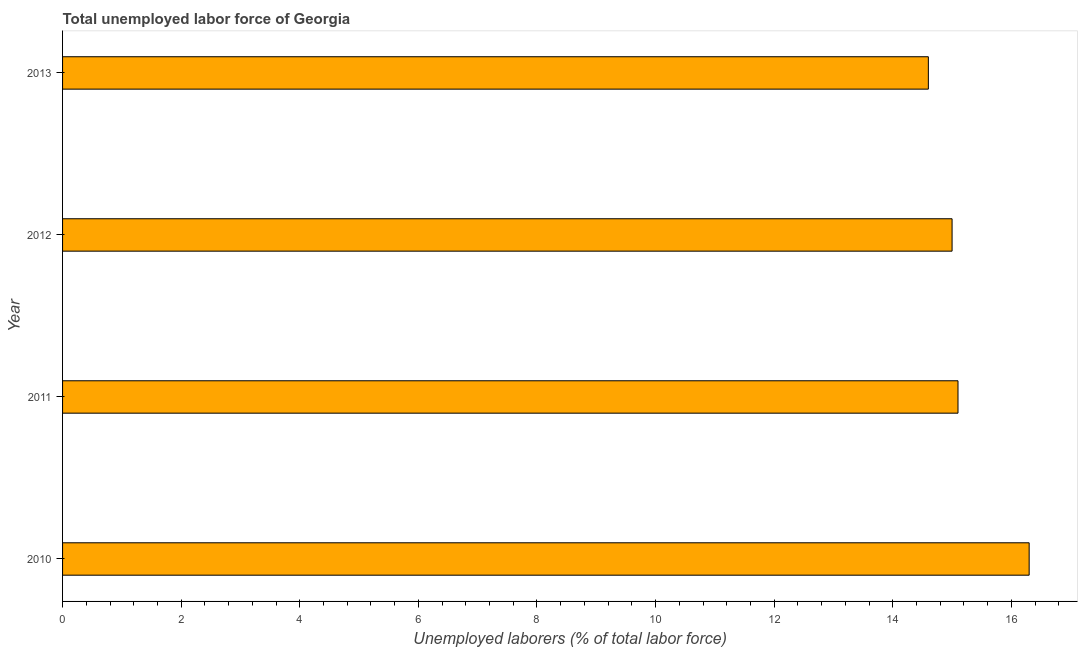What is the title of the graph?
Provide a succinct answer. Total unemployed labor force of Georgia. What is the label or title of the X-axis?
Your answer should be very brief. Unemployed laborers (% of total labor force). What is the label or title of the Y-axis?
Provide a succinct answer. Year. What is the total unemployed labour force in 2011?
Keep it short and to the point. 15.1. Across all years, what is the maximum total unemployed labour force?
Keep it short and to the point. 16.3. Across all years, what is the minimum total unemployed labour force?
Your answer should be compact. 14.6. What is the sum of the total unemployed labour force?
Provide a short and direct response. 61. What is the difference between the total unemployed labour force in 2010 and 2012?
Offer a terse response. 1.3. What is the average total unemployed labour force per year?
Make the answer very short. 15.25. What is the median total unemployed labour force?
Offer a terse response. 15.05. In how many years, is the total unemployed labour force greater than 8.4 %?
Provide a succinct answer. 4. Do a majority of the years between 2011 and 2012 (inclusive) have total unemployed labour force greater than 2 %?
Ensure brevity in your answer.  Yes. Is the difference between the total unemployed labour force in 2011 and 2012 greater than the difference between any two years?
Your answer should be very brief. No. What is the difference between the highest and the second highest total unemployed labour force?
Offer a terse response. 1.2. What is the difference between the highest and the lowest total unemployed labour force?
Your answer should be compact. 1.7. How many bars are there?
Offer a very short reply. 4. Are all the bars in the graph horizontal?
Ensure brevity in your answer.  Yes. How many years are there in the graph?
Make the answer very short. 4. What is the difference between two consecutive major ticks on the X-axis?
Provide a succinct answer. 2. What is the Unemployed laborers (% of total labor force) in 2010?
Provide a short and direct response. 16.3. What is the Unemployed laborers (% of total labor force) in 2011?
Make the answer very short. 15.1. What is the Unemployed laborers (% of total labor force) in 2012?
Your answer should be very brief. 15. What is the Unemployed laborers (% of total labor force) of 2013?
Ensure brevity in your answer.  14.6. What is the difference between the Unemployed laborers (% of total labor force) in 2010 and 2012?
Offer a very short reply. 1.3. What is the difference between the Unemployed laborers (% of total labor force) in 2010 and 2013?
Provide a succinct answer. 1.7. What is the difference between the Unemployed laborers (% of total labor force) in 2011 and 2012?
Provide a succinct answer. 0.1. What is the difference between the Unemployed laborers (% of total labor force) in 2011 and 2013?
Offer a very short reply. 0.5. What is the ratio of the Unemployed laborers (% of total labor force) in 2010 to that in 2011?
Provide a short and direct response. 1.08. What is the ratio of the Unemployed laborers (% of total labor force) in 2010 to that in 2012?
Your response must be concise. 1.09. What is the ratio of the Unemployed laborers (% of total labor force) in 2010 to that in 2013?
Offer a very short reply. 1.12. What is the ratio of the Unemployed laborers (% of total labor force) in 2011 to that in 2013?
Your answer should be very brief. 1.03. What is the ratio of the Unemployed laborers (% of total labor force) in 2012 to that in 2013?
Offer a terse response. 1.03. 